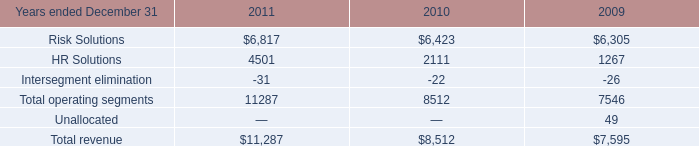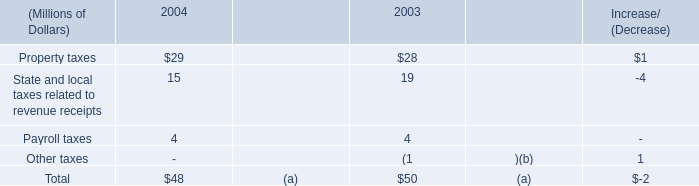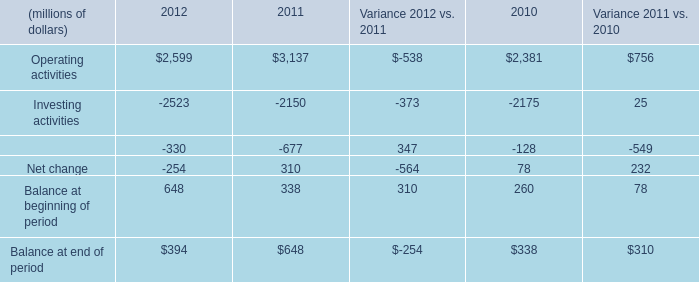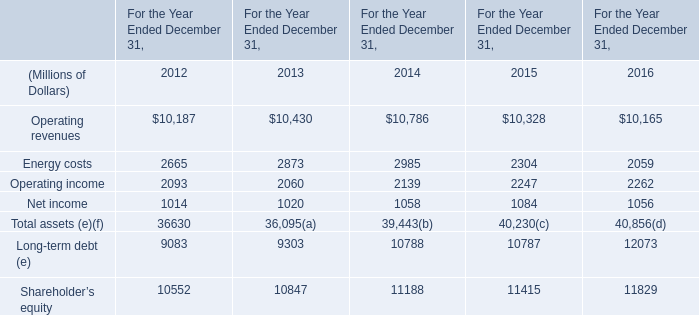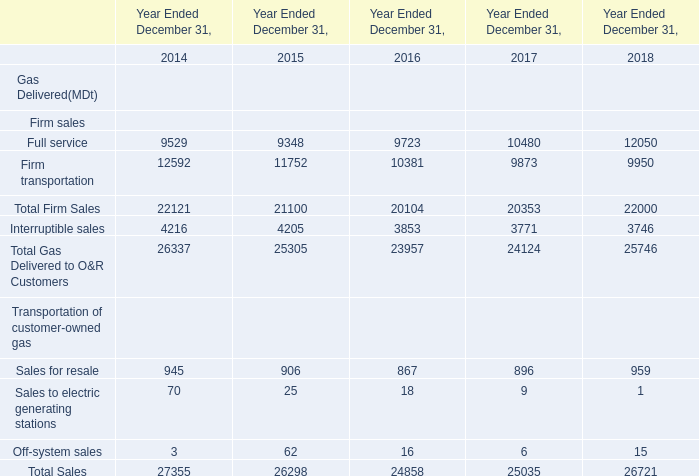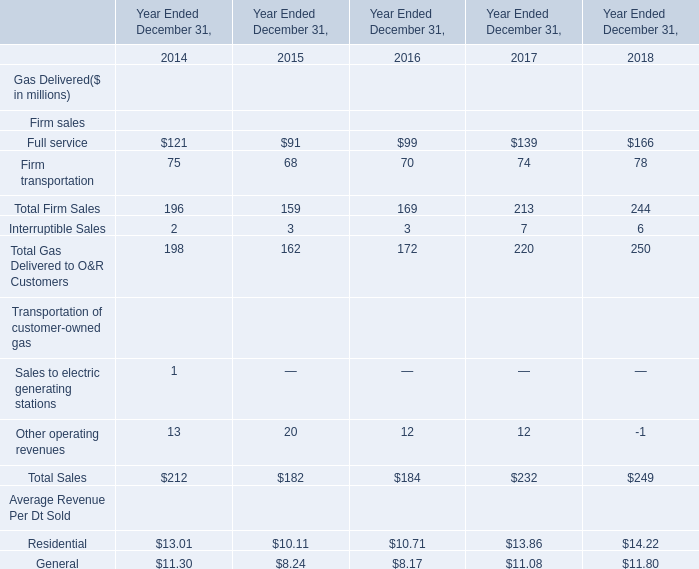What was the total amount of elements greater than 150 in 2014? (in million) 
Computations: ((196 + 198) + 212)
Answer: 606.0. 